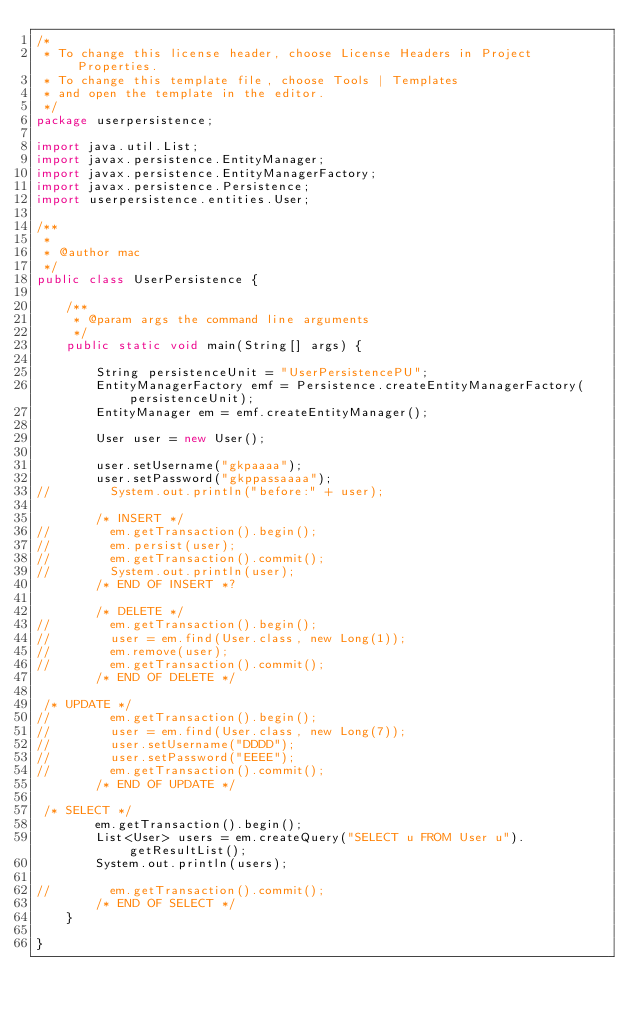Convert code to text. <code><loc_0><loc_0><loc_500><loc_500><_Java_>/*
 * To change this license header, choose License Headers in Project Properties.
 * To change this template file, choose Tools | Templates
 * and open the template in the editor.
 */
package userpersistence;

import java.util.List;
import javax.persistence.EntityManager;
import javax.persistence.EntityManagerFactory;
import javax.persistence.Persistence;
import userpersistence.entities.User;

/**
 *
 * @author mac
 */
public class UserPersistence {

    /**
     * @param args the command line arguments
     */
    public static void main(String[] args) {

        String persistenceUnit = "UserPersistencePU";
        EntityManagerFactory emf = Persistence.createEntityManagerFactory(persistenceUnit);
        EntityManager em = emf.createEntityManager();

        User user = new User();

        user.setUsername("gkpaaaa");
        user.setPassword("gkppassaaaa");
//        System.out.println("before:" + user);

        /* INSERT */
//        em.getTransaction().begin();
//        em.persist(user);
//        em.getTransaction().commit();
//        System.out.println(user);
        /* END OF INSERT *?
        
        /* DELETE */
//        em.getTransaction().begin();
//        user = em.find(User.class, new Long(1));
//        em.remove(user);
//        em.getTransaction().commit();
        /* END OF DELETE */

 /* UPDATE */
//        em.getTransaction().begin();
//        user = em.find(User.class, new Long(7));
//        user.setUsername("DDDD");
//        user.setPassword("EEEE");
//        em.getTransaction().commit();
        /* END OF UPDATE */

 /* SELECT */
        em.getTransaction().begin();
        List<User> users = em.createQuery("SELECT u FROM User u").getResultList();
        System.out.println(users);

//        em.getTransaction().commit();
        /* END OF SELECT */
    }

}
</code> 